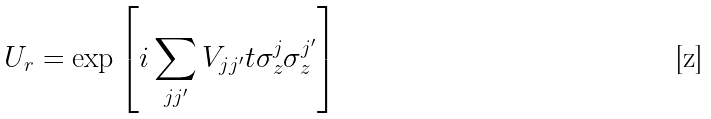Convert formula to latex. <formula><loc_0><loc_0><loc_500><loc_500>U _ { r } = \exp \left [ i \sum _ { j j ^ { \prime } } V _ { j j ^ { \prime } } t \sigma _ { z } ^ { j } \sigma _ { z } ^ { j ^ { \prime } } \right ]</formula> 